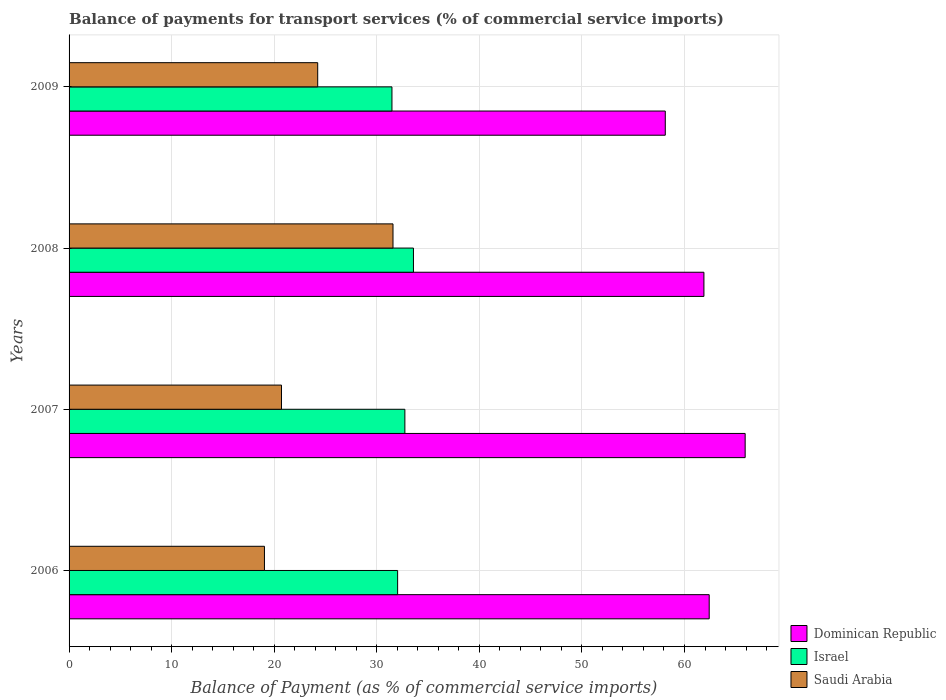How many groups of bars are there?
Give a very brief answer. 4. Are the number of bars on each tick of the Y-axis equal?
Your response must be concise. Yes. What is the label of the 4th group of bars from the top?
Offer a terse response. 2006. What is the balance of payments for transport services in Saudi Arabia in 2009?
Offer a very short reply. 24.24. Across all years, what is the maximum balance of payments for transport services in Dominican Republic?
Your answer should be very brief. 65.92. Across all years, what is the minimum balance of payments for transport services in Israel?
Your response must be concise. 31.48. What is the total balance of payments for transport services in Israel in the graph?
Your response must be concise. 129.83. What is the difference between the balance of payments for transport services in Israel in 2006 and that in 2009?
Keep it short and to the point. 0.55. What is the difference between the balance of payments for transport services in Israel in 2008 and the balance of payments for transport services in Dominican Republic in 2007?
Provide a succinct answer. -32.34. What is the average balance of payments for transport services in Saudi Arabia per year?
Provide a short and direct response. 23.9. In the year 2009, what is the difference between the balance of payments for transport services in Saudi Arabia and balance of payments for transport services in Dominican Republic?
Provide a short and direct response. -33.89. In how many years, is the balance of payments for transport services in Israel greater than 16 %?
Make the answer very short. 4. What is the ratio of the balance of payments for transport services in Israel in 2006 to that in 2008?
Make the answer very short. 0.95. What is the difference between the highest and the second highest balance of payments for transport services in Dominican Republic?
Your answer should be compact. 3.5. What is the difference between the highest and the lowest balance of payments for transport services in Dominican Republic?
Your response must be concise. 7.79. In how many years, is the balance of payments for transport services in Israel greater than the average balance of payments for transport services in Israel taken over all years?
Your answer should be compact. 2. What does the 3rd bar from the bottom in 2008 represents?
Offer a very short reply. Saudi Arabia. How many bars are there?
Offer a terse response. 12. How many years are there in the graph?
Offer a terse response. 4. Does the graph contain any zero values?
Your answer should be very brief. No. Where does the legend appear in the graph?
Your answer should be compact. Bottom right. How many legend labels are there?
Provide a short and direct response. 3. How are the legend labels stacked?
Keep it short and to the point. Vertical. What is the title of the graph?
Your answer should be compact. Balance of payments for transport services (% of commercial service imports). What is the label or title of the X-axis?
Make the answer very short. Balance of Payment (as % of commercial service imports). What is the Balance of Payment (as % of commercial service imports) of Dominican Republic in 2006?
Your answer should be very brief. 62.41. What is the Balance of Payment (as % of commercial service imports) of Israel in 2006?
Offer a very short reply. 32.03. What is the Balance of Payment (as % of commercial service imports) of Saudi Arabia in 2006?
Provide a succinct answer. 19.05. What is the Balance of Payment (as % of commercial service imports) of Dominican Republic in 2007?
Your answer should be very brief. 65.92. What is the Balance of Payment (as % of commercial service imports) of Israel in 2007?
Your answer should be very brief. 32.74. What is the Balance of Payment (as % of commercial service imports) of Saudi Arabia in 2007?
Provide a succinct answer. 20.71. What is the Balance of Payment (as % of commercial service imports) of Dominican Republic in 2008?
Ensure brevity in your answer.  61.9. What is the Balance of Payment (as % of commercial service imports) in Israel in 2008?
Provide a short and direct response. 33.58. What is the Balance of Payment (as % of commercial service imports) in Saudi Arabia in 2008?
Offer a very short reply. 31.58. What is the Balance of Payment (as % of commercial service imports) in Dominican Republic in 2009?
Provide a succinct answer. 58.13. What is the Balance of Payment (as % of commercial service imports) in Israel in 2009?
Provide a short and direct response. 31.48. What is the Balance of Payment (as % of commercial service imports) in Saudi Arabia in 2009?
Offer a very short reply. 24.24. Across all years, what is the maximum Balance of Payment (as % of commercial service imports) in Dominican Republic?
Provide a short and direct response. 65.92. Across all years, what is the maximum Balance of Payment (as % of commercial service imports) of Israel?
Your answer should be compact. 33.58. Across all years, what is the maximum Balance of Payment (as % of commercial service imports) of Saudi Arabia?
Offer a very short reply. 31.58. Across all years, what is the minimum Balance of Payment (as % of commercial service imports) of Dominican Republic?
Give a very brief answer. 58.13. Across all years, what is the minimum Balance of Payment (as % of commercial service imports) of Israel?
Make the answer very short. 31.48. Across all years, what is the minimum Balance of Payment (as % of commercial service imports) of Saudi Arabia?
Offer a terse response. 19.05. What is the total Balance of Payment (as % of commercial service imports) in Dominican Republic in the graph?
Ensure brevity in your answer.  248.35. What is the total Balance of Payment (as % of commercial service imports) of Israel in the graph?
Offer a very short reply. 129.83. What is the total Balance of Payment (as % of commercial service imports) of Saudi Arabia in the graph?
Give a very brief answer. 95.58. What is the difference between the Balance of Payment (as % of commercial service imports) in Dominican Republic in 2006 and that in 2007?
Your response must be concise. -3.5. What is the difference between the Balance of Payment (as % of commercial service imports) in Israel in 2006 and that in 2007?
Offer a terse response. -0.71. What is the difference between the Balance of Payment (as % of commercial service imports) in Saudi Arabia in 2006 and that in 2007?
Provide a short and direct response. -1.66. What is the difference between the Balance of Payment (as % of commercial service imports) of Dominican Republic in 2006 and that in 2008?
Make the answer very short. 0.52. What is the difference between the Balance of Payment (as % of commercial service imports) in Israel in 2006 and that in 2008?
Ensure brevity in your answer.  -1.54. What is the difference between the Balance of Payment (as % of commercial service imports) of Saudi Arabia in 2006 and that in 2008?
Make the answer very short. -12.53. What is the difference between the Balance of Payment (as % of commercial service imports) of Dominican Republic in 2006 and that in 2009?
Make the answer very short. 4.28. What is the difference between the Balance of Payment (as % of commercial service imports) in Israel in 2006 and that in 2009?
Give a very brief answer. 0.55. What is the difference between the Balance of Payment (as % of commercial service imports) in Saudi Arabia in 2006 and that in 2009?
Your answer should be compact. -5.19. What is the difference between the Balance of Payment (as % of commercial service imports) of Dominican Republic in 2007 and that in 2008?
Provide a succinct answer. 4.02. What is the difference between the Balance of Payment (as % of commercial service imports) in Israel in 2007 and that in 2008?
Provide a succinct answer. -0.84. What is the difference between the Balance of Payment (as % of commercial service imports) in Saudi Arabia in 2007 and that in 2008?
Offer a terse response. -10.87. What is the difference between the Balance of Payment (as % of commercial service imports) of Dominican Republic in 2007 and that in 2009?
Offer a terse response. 7.79. What is the difference between the Balance of Payment (as % of commercial service imports) in Israel in 2007 and that in 2009?
Your response must be concise. 1.26. What is the difference between the Balance of Payment (as % of commercial service imports) in Saudi Arabia in 2007 and that in 2009?
Provide a succinct answer. -3.53. What is the difference between the Balance of Payment (as % of commercial service imports) of Dominican Republic in 2008 and that in 2009?
Give a very brief answer. 3.77. What is the difference between the Balance of Payment (as % of commercial service imports) in Israel in 2008 and that in 2009?
Provide a succinct answer. 2.1. What is the difference between the Balance of Payment (as % of commercial service imports) of Saudi Arabia in 2008 and that in 2009?
Make the answer very short. 7.34. What is the difference between the Balance of Payment (as % of commercial service imports) in Dominican Republic in 2006 and the Balance of Payment (as % of commercial service imports) in Israel in 2007?
Ensure brevity in your answer.  29.67. What is the difference between the Balance of Payment (as % of commercial service imports) in Dominican Republic in 2006 and the Balance of Payment (as % of commercial service imports) in Saudi Arabia in 2007?
Provide a short and direct response. 41.7. What is the difference between the Balance of Payment (as % of commercial service imports) in Israel in 2006 and the Balance of Payment (as % of commercial service imports) in Saudi Arabia in 2007?
Your response must be concise. 11.32. What is the difference between the Balance of Payment (as % of commercial service imports) of Dominican Republic in 2006 and the Balance of Payment (as % of commercial service imports) of Israel in 2008?
Offer a terse response. 28.83. What is the difference between the Balance of Payment (as % of commercial service imports) in Dominican Republic in 2006 and the Balance of Payment (as % of commercial service imports) in Saudi Arabia in 2008?
Offer a terse response. 30.83. What is the difference between the Balance of Payment (as % of commercial service imports) of Israel in 2006 and the Balance of Payment (as % of commercial service imports) of Saudi Arabia in 2008?
Offer a very short reply. 0.45. What is the difference between the Balance of Payment (as % of commercial service imports) in Dominican Republic in 2006 and the Balance of Payment (as % of commercial service imports) in Israel in 2009?
Offer a terse response. 30.93. What is the difference between the Balance of Payment (as % of commercial service imports) of Dominican Republic in 2006 and the Balance of Payment (as % of commercial service imports) of Saudi Arabia in 2009?
Ensure brevity in your answer.  38.17. What is the difference between the Balance of Payment (as % of commercial service imports) of Israel in 2006 and the Balance of Payment (as % of commercial service imports) of Saudi Arabia in 2009?
Make the answer very short. 7.79. What is the difference between the Balance of Payment (as % of commercial service imports) in Dominican Republic in 2007 and the Balance of Payment (as % of commercial service imports) in Israel in 2008?
Ensure brevity in your answer.  32.34. What is the difference between the Balance of Payment (as % of commercial service imports) in Dominican Republic in 2007 and the Balance of Payment (as % of commercial service imports) in Saudi Arabia in 2008?
Provide a succinct answer. 34.33. What is the difference between the Balance of Payment (as % of commercial service imports) of Israel in 2007 and the Balance of Payment (as % of commercial service imports) of Saudi Arabia in 2008?
Keep it short and to the point. 1.16. What is the difference between the Balance of Payment (as % of commercial service imports) of Dominican Republic in 2007 and the Balance of Payment (as % of commercial service imports) of Israel in 2009?
Offer a very short reply. 34.44. What is the difference between the Balance of Payment (as % of commercial service imports) in Dominican Republic in 2007 and the Balance of Payment (as % of commercial service imports) in Saudi Arabia in 2009?
Make the answer very short. 41.67. What is the difference between the Balance of Payment (as % of commercial service imports) in Israel in 2007 and the Balance of Payment (as % of commercial service imports) in Saudi Arabia in 2009?
Make the answer very short. 8.5. What is the difference between the Balance of Payment (as % of commercial service imports) in Dominican Republic in 2008 and the Balance of Payment (as % of commercial service imports) in Israel in 2009?
Offer a terse response. 30.42. What is the difference between the Balance of Payment (as % of commercial service imports) of Dominican Republic in 2008 and the Balance of Payment (as % of commercial service imports) of Saudi Arabia in 2009?
Your answer should be very brief. 37.65. What is the difference between the Balance of Payment (as % of commercial service imports) of Israel in 2008 and the Balance of Payment (as % of commercial service imports) of Saudi Arabia in 2009?
Provide a short and direct response. 9.34. What is the average Balance of Payment (as % of commercial service imports) in Dominican Republic per year?
Offer a terse response. 62.09. What is the average Balance of Payment (as % of commercial service imports) in Israel per year?
Your answer should be compact. 32.46. What is the average Balance of Payment (as % of commercial service imports) in Saudi Arabia per year?
Offer a very short reply. 23.9. In the year 2006, what is the difference between the Balance of Payment (as % of commercial service imports) in Dominican Republic and Balance of Payment (as % of commercial service imports) in Israel?
Keep it short and to the point. 30.38. In the year 2006, what is the difference between the Balance of Payment (as % of commercial service imports) of Dominican Republic and Balance of Payment (as % of commercial service imports) of Saudi Arabia?
Your answer should be compact. 43.36. In the year 2006, what is the difference between the Balance of Payment (as % of commercial service imports) of Israel and Balance of Payment (as % of commercial service imports) of Saudi Arabia?
Provide a short and direct response. 12.98. In the year 2007, what is the difference between the Balance of Payment (as % of commercial service imports) in Dominican Republic and Balance of Payment (as % of commercial service imports) in Israel?
Your answer should be compact. 33.18. In the year 2007, what is the difference between the Balance of Payment (as % of commercial service imports) in Dominican Republic and Balance of Payment (as % of commercial service imports) in Saudi Arabia?
Give a very brief answer. 45.21. In the year 2007, what is the difference between the Balance of Payment (as % of commercial service imports) of Israel and Balance of Payment (as % of commercial service imports) of Saudi Arabia?
Offer a very short reply. 12.03. In the year 2008, what is the difference between the Balance of Payment (as % of commercial service imports) in Dominican Republic and Balance of Payment (as % of commercial service imports) in Israel?
Offer a terse response. 28.32. In the year 2008, what is the difference between the Balance of Payment (as % of commercial service imports) in Dominican Republic and Balance of Payment (as % of commercial service imports) in Saudi Arabia?
Make the answer very short. 30.31. In the year 2008, what is the difference between the Balance of Payment (as % of commercial service imports) of Israel and Balance of Payment (as % of commercial service imports) of Saudi Arabia?
Provide a succinct answer. 1.99. In the year 2009, what is the difference between the Balance of Payment (as % of commercial service imports) of Dominican Republic and Balance of Payment (as % of commercial service imports) of Israel?
Your answer should be very brief. 26.65. In the year 2009, what is the difference between the Balance of Payment (as % of commercial service imports) of Dominican Republic and Balance of Payment (as % of commercial service imports) of Saudi Arabia?
Provide a short and direct response. 33.89. In the year 2009, what is the difference between the Balance of Payment (as % of commercial service imports) of Israel and Balance of Payment (as % of commercial service imports) of Saudi Arabia?
Offer a terse response. 7.24. What is the ratio of the Balance of Payment (as % of commercial service imports) of Dominican Republic in 2006 to that in 2007?
Make the answer very short. 0.95. What is the ratio of the Balance of Payment (as % of commercial service imports) in Israel in 2006 to that in 2007?
Provide a succinct answer. 0.98. What is the ratio of the Balance of Payment (as % of commercial service imports) of Saudi Arabia in 2006 to that in 2007?
Offer a very short reply. 0.92. What is the ratio of the Balance of Payment (as % of commercial service imports) of Dominican Republic in 2006 to that in 2008?
Make the answer very short. 1.01. What is the ratio of the Balance of Payment (as % of commercial service imports) in Israel in 2006 to that in 2008?
Give a very brief answer. 0.95. What is the ratio of the Balance of Payment (as % of commercial service imports) of Saudi Arabia in 2006 to that in 2008?
Make the answer very short. 0.6. What is the ratio of the Balance of Payment (as % of commercial service imports) of Dominican Republic in 2006 to that in 2009?
Give a very brief answer. 1.07. What is the ratio of the Balance of Payment (as % of commercial service imports) of Israel in 2006 to that in 2009?
Your response must be concise. 1.02. What is the ratio of the Balance of Payment (as % of commercial service imports) in Saudi Arabia in 2006 to that in 2009?
Provide a succinct answer. 0.79. What is the ratio of the Balance of Payment (as % of commercial service imports) of Dominican Republic in 2007 to that in 2008?
Offer a very short reply. 1.06. What is the ratio of the Balance of Payment (as % of commercial service imports) in Israel in 2007 to that in 2008?
Ensure brevity in your answer.  0.98. What is the ratio of the Balance of Payment (as % of commercial service imports) of Saudi Arabia in 2007 to that in 2008?
Ensure brevity in your answer.  0.66. What is the ratio of the Balance of Payment (as % of commercial service imports) of Dominican Republic in 2007 to that in 2009?
Make the answer very short. 1.13. What is the ratio of the Balance of Payment (as % of commercial service imports) in Saudi Arabia in 2007 to that in 2009?
Your answer should be compact. 0.85. What is the ratio of the Balance of Payment (as % of commercial service imports) of Dominican Republic in 2008 to that in 2009?
Give a very brief answer. 1.06. What is the ratio of the Balance of Payment (as % of commercial service imports) of Israel in 2008 to that in 2009?
Provide a short and direct response. 1.07. What is the ratio of the Balance of Payment (as % of commercial service imports) in Saudi Arabia in 2008 to that in 2009?
Offer a terse response. 1.3. What is the difference between the highest and the second highest Balance of Payment (as % of commercial service imports) of Dominican Republic?
Ensure brevity in your answer.  3.5. What is the difference between the highest and the second highest Balance of Payment (as % of commercial service imports) of Israel?
Provide a short and direct response. 0.84. What is the difference between the highest and the second highest Balance of Payment (as % of commercial service imports) of Saudi Arabia?
Your answer should be compact. 7.34. What is the difference between the highest and the lowest Balance of Payment (as % of commercial service imports) in Dominican Republic?
Keep it short and to the point. 7.79. What is the difference between the highest and the lowest Balance of Payment (as % of commercial service imports) in Israel?
Provide a succinct answer. 2.1. What is the difference between the highest and the lowest Balance of Payment (as % of commercial service imports) of Saudi Arabia?
Offer a very short reply. 12.53. 